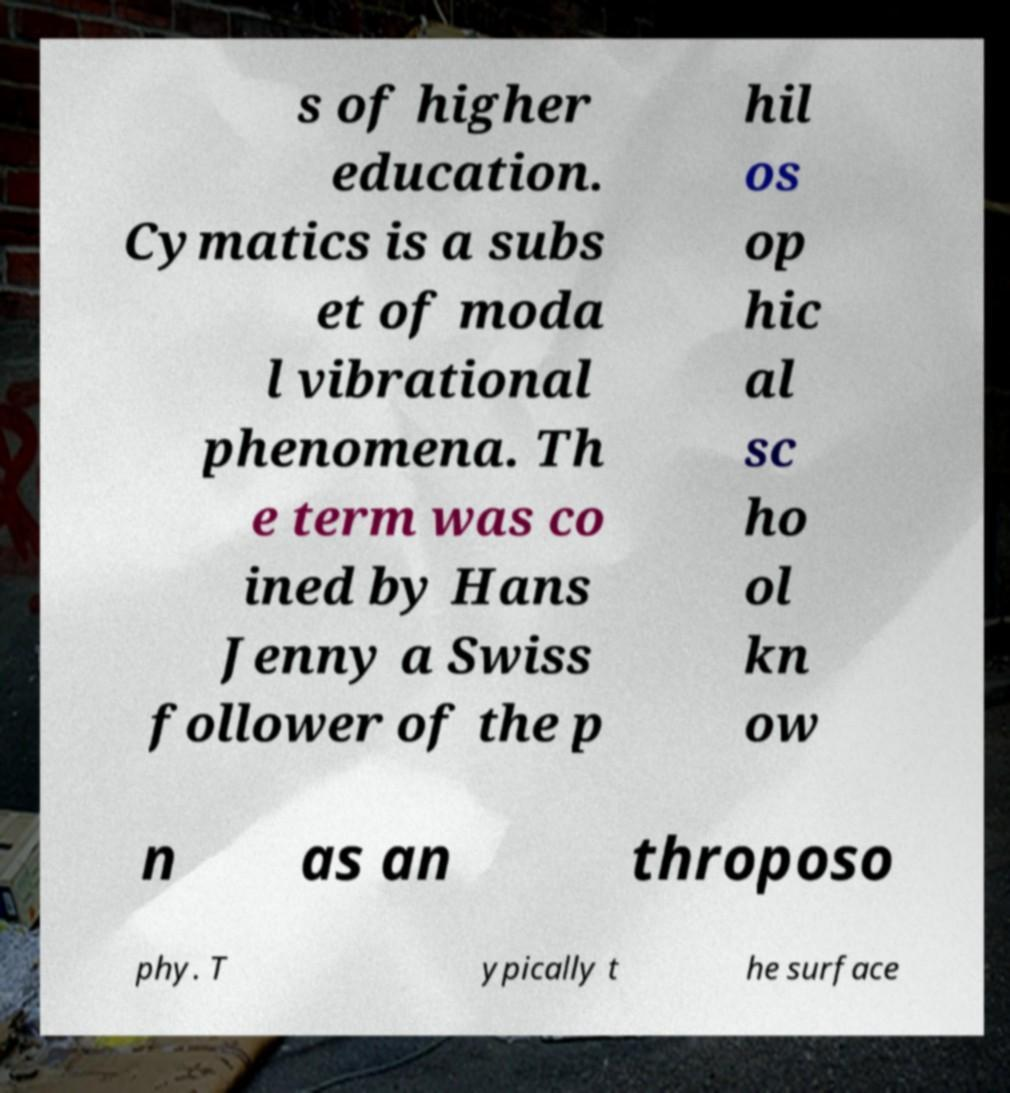Could you extract and type out the text from this image? s of higher education. Cymatics is a subs et of moda l vibrational phenomena. Th e term was co ined by Hans Jenny a Swiss follower of the p hil os op hic al sc ho ol kn ow n as an throposo phy. T ypically t he surface 